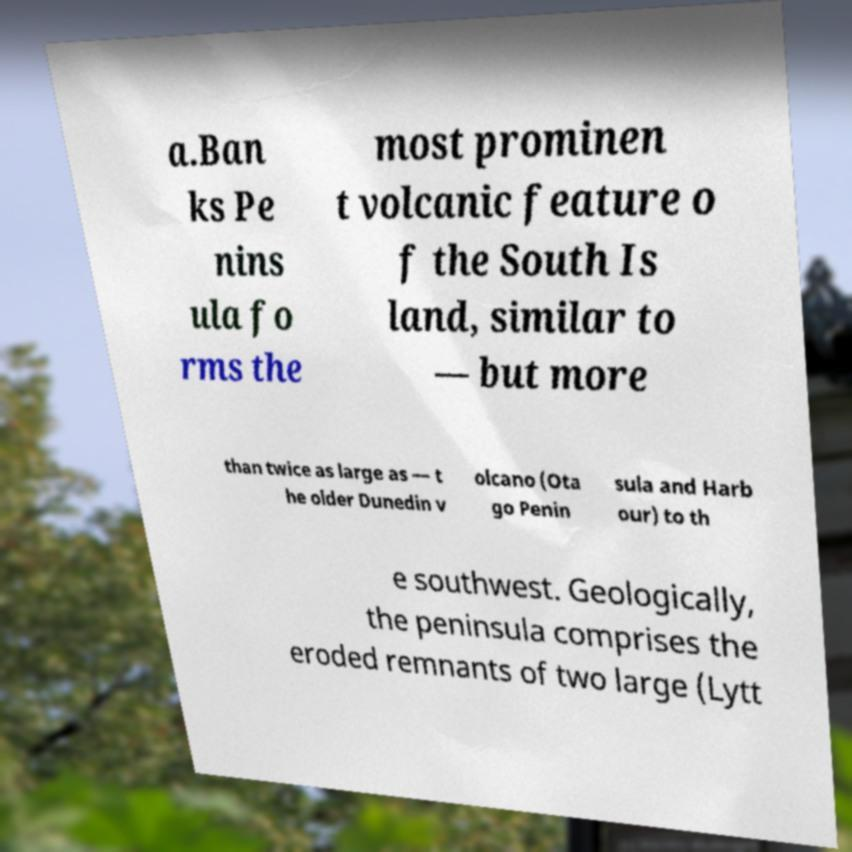What messages or text are displayed in this image? I need them in a readable, typed format. a.Ban ks Pe nins ula fo rms the most prominen t volcanic feature o f the South Is land, similar to — but more than twice as large as — t he older Dunedin v olcano (Ota go Penin sula and Harb our) to th e southwest. Geologically, the peninsula comprises the eroded remnants of two large (Lytt 